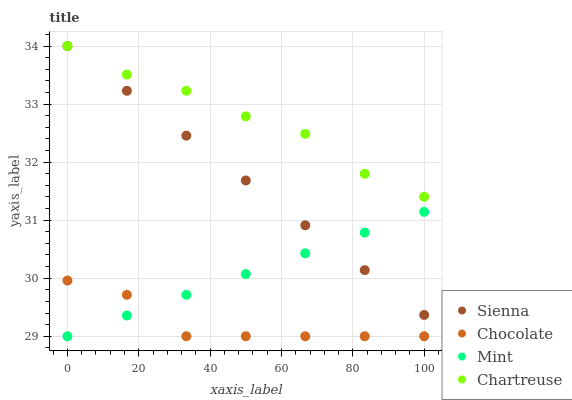Does Chocolate have the minimum area under the curve?
Answer yes or no. Yes. Does Chartreuse have the maximum area under the curve?
Answer yes or no. Yes. Does Mint have the minimum area under the curve?
Answer yes or no. No. Does Mint have the maximum area under the curve?
Answer yes or no. No. Is Mint the smoothest?
Answer yes or no. Yes. Is Chartreuse the roughest?
Answer yes or no. Yes. Is Chartreuse the smoothest?
Answer yes or no. No. Is Mint the roughest?
Answer yes or no. No. Does Mint have the lowest value?
Answer yes or no. Yes. Does Chartreuse have the lowest value?
Answer yes or no. No. Does Chartreuse have the highest value?
Answer yes or no. Yes. Does Mint have the highest value?
Answer yes or no. No. Is Chocolate less than Chartreuse?
Answer yes or no. Yes. Is Chartreuse greater than Mint?
Answer yes or no. Yes. Does Chartreuse intersect Sienna?
Answer yes or no. Yes. Is Chartreuse less than Sienna?
Answer yes or no. No. Is Chartreuse greater than Sienna?
Answer yes or no. No. Does Chocolate intersect Chartreuse?
Answer yes or no. No. 